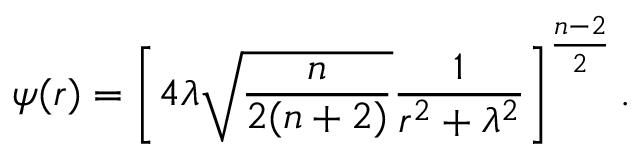<formula> <loc_0><loc_0><loc_500><loc_500>\psi ( r ) = \left [ 4 \lambda \sqrt { { \frac { n } { 2 ( n + 2 ) } } } { \frac { 1 } { r ^ { 2 } + \lambda ^ { 2 } } } \right ] ^ { \frac { n - 2 } { 2 } } .</formula> 